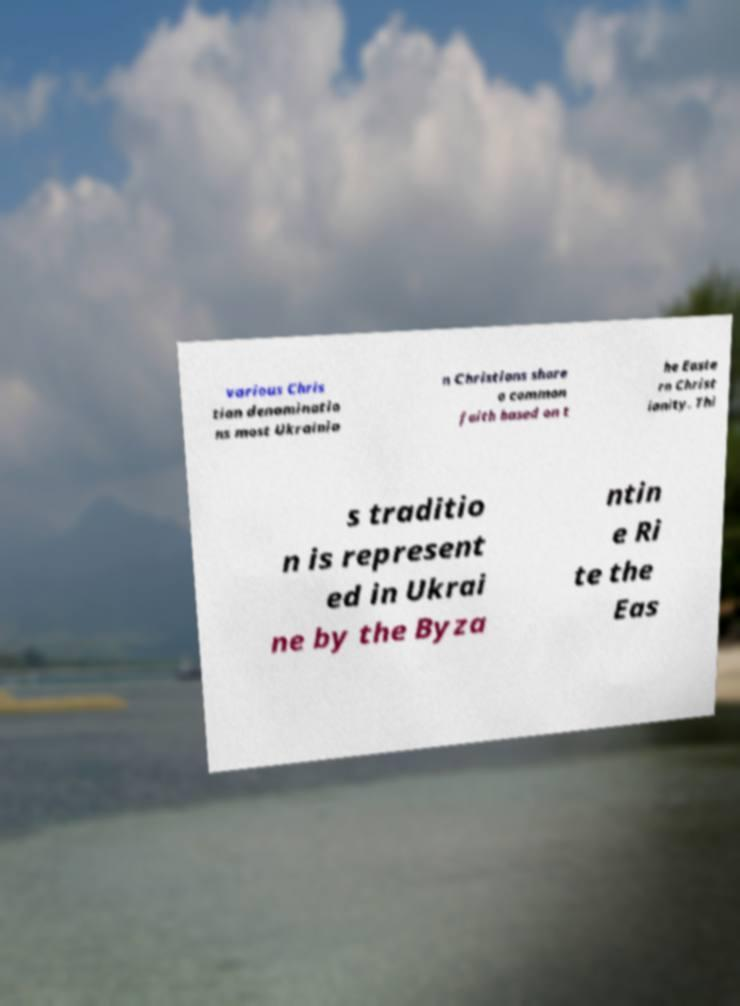Can you read and provide the text displayed in the image?This photo seems to have some interesting text. Can you extract and type it out for me? various Chris tian denominatio ns most Ukrainia n Christians share a common faith based on t he Easte rn Christ ianity. Thi s traditio n is represent ed in Ukrai ne by the Byza ntin e Ri te the Eas 